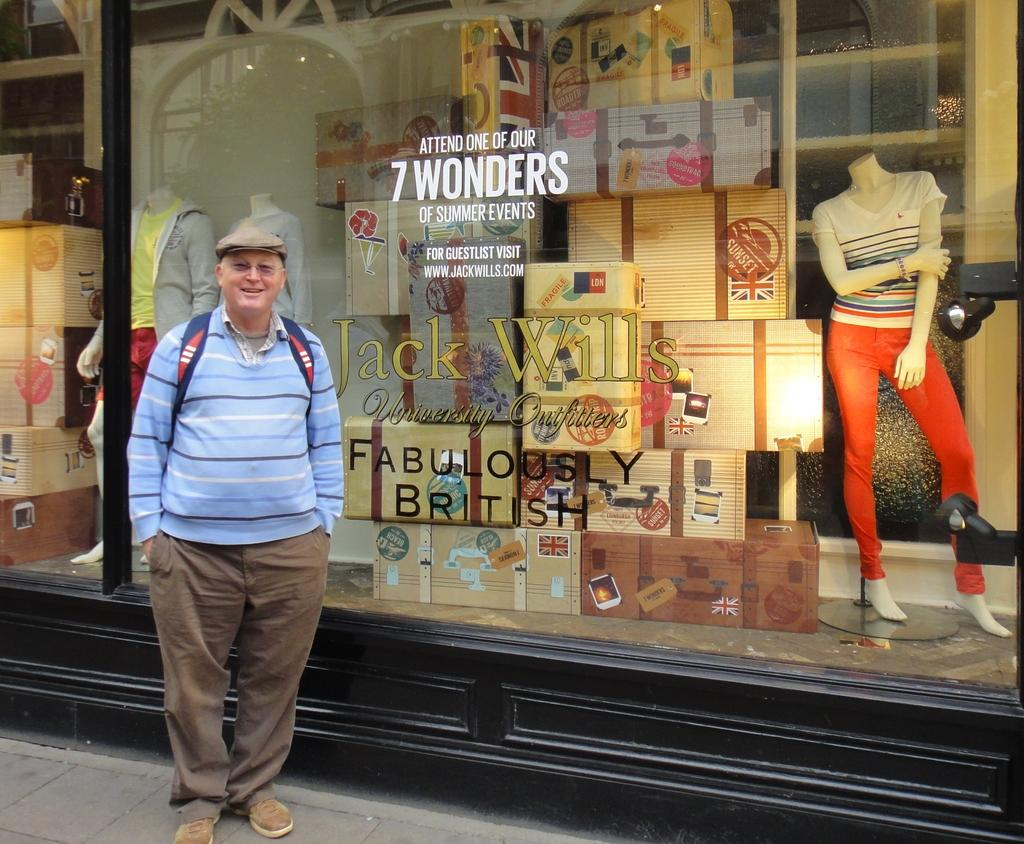What is the man in the image doing? The man is standing and smiling in the image. What can be seen in the background of the image? Mannequins and boxes are visible through the glass in the background. What is the purpose of the glass in the image? The glass has text on it and provides a view of the mannequins and boxes in the background. How many mannequins are visible through the glass? The number of mannequins visible through the glass cannot be determined from the image. Can you see any horns on the mannequins through the glass? There are no horns visible on the mannequins through the glass in the image. 